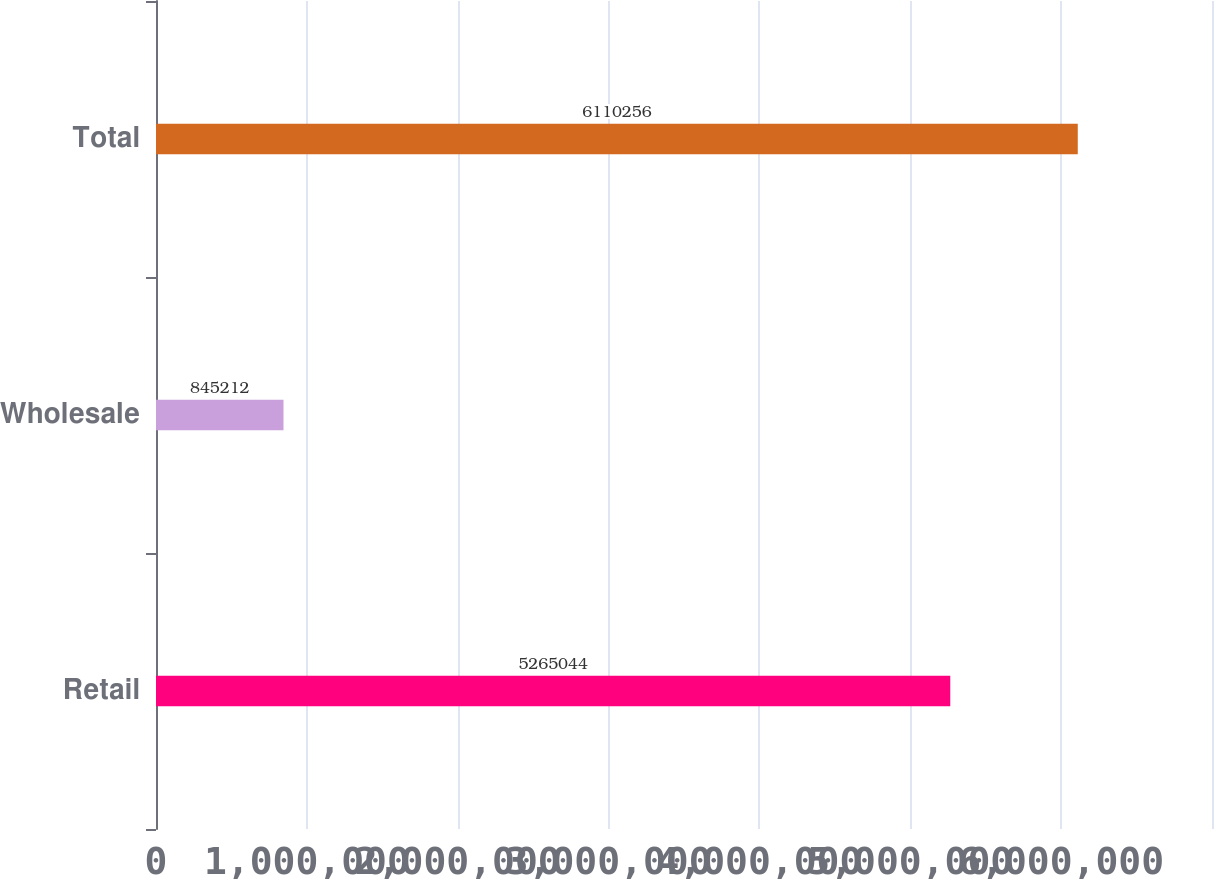<chart> <loc_0><loc_0><loc_500><loc_500><bar_chart><fcel>Retail<fcel>Wholesale<fcel>Total<nl><fcel>5.26504e+06<fcel>845212<fcel>6.11026e+06<nl></chart> 